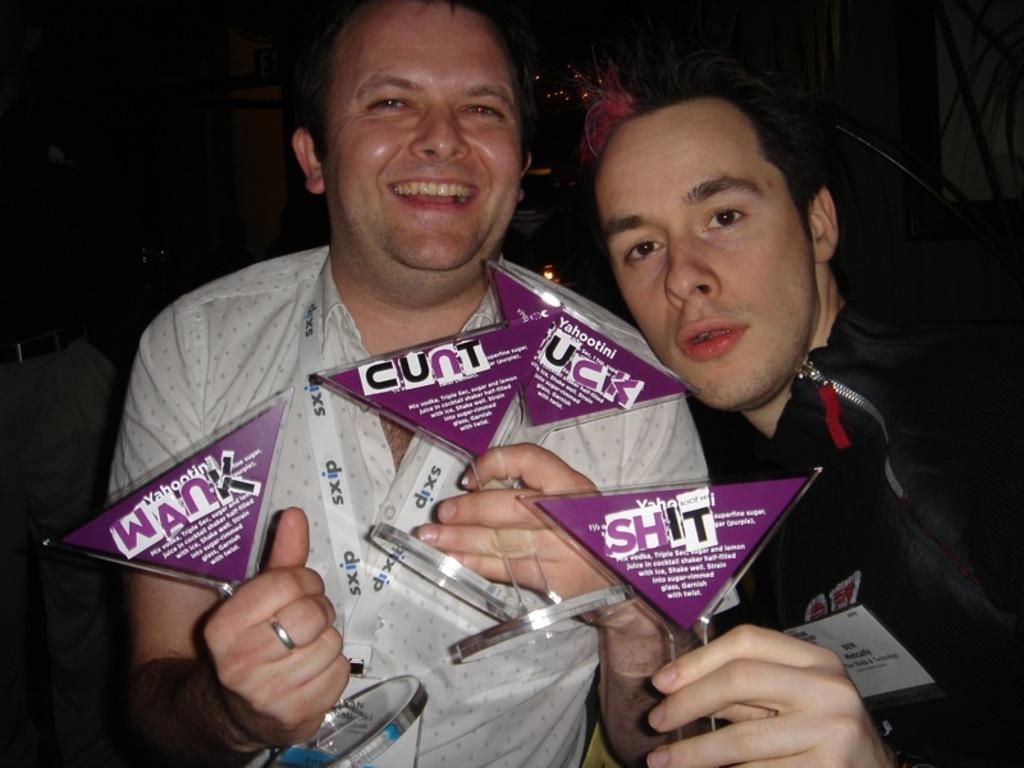In one or two sentences, can you explain what this image depicts? In the picture I can see two persons holding few objects in their hands and there are some other objects in the background. 